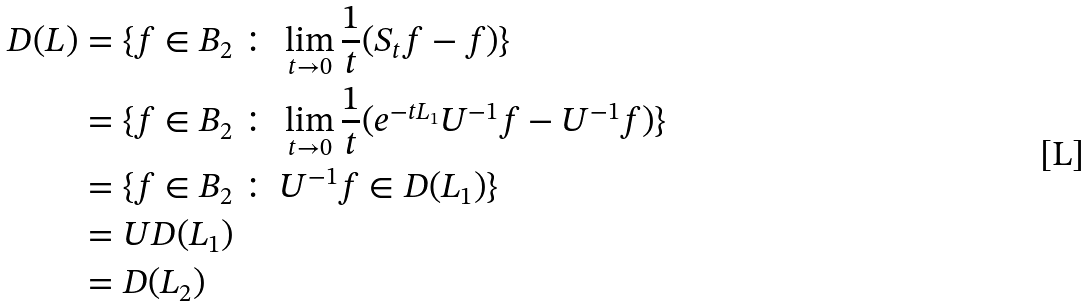Convert formula to latex. <formula><loc_0><loc_0><loc_500><loc_500>D ( L ) & = \{ f \in B _ { 2 } \, \colon \, \lim _ { t \to 0 } \frac { 1 } { t } ( S _ { t } f - f ) \} \\ & = \{ f \in B _ { 2 } \, \colon \, \lim _ { t \to 0 } \frac { 1 } { t } ( e ^ { - t L _ { 1 } } U ^ { - 1 } f - U ^ { - 1 } f ) \} \\ & = \{ f \in B _ { 2 } \, \colon \, U ^ { - 1 } f \in D ( L _ { 1 } ) \} \\ & = U D ( L _ { 1 } ) \\ & = D ( L _ { 2 } )</formula> 